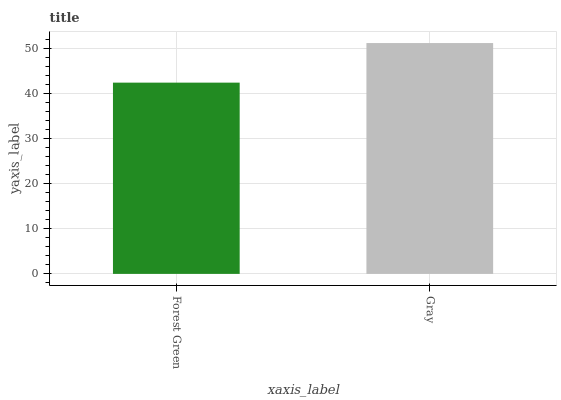Is Forest Green the minimum?
Answer yes or no. Yes. Is Gray the maximum?
Answer yes or no. Yes. Is Gray the minimum?
Answer yes or no. No. Is Gray greater than Forest Green?
Answer yes or no. Yes. Is Forest Green less than Gray?
Answer yes or no. Yes. Is Forest Green greater than Gray?
Answer yes or no. No. Is Gray less than Forest Green?
Answer yes or no. No. Is Gray the high median?
Answer yes or no. Yes. Is Forest Green the low median?
Answer yes or no. Yes. Is Forest Green the high median?
Answer yes or no. No. Is Gray the low median?
Answer yes or no. No. 